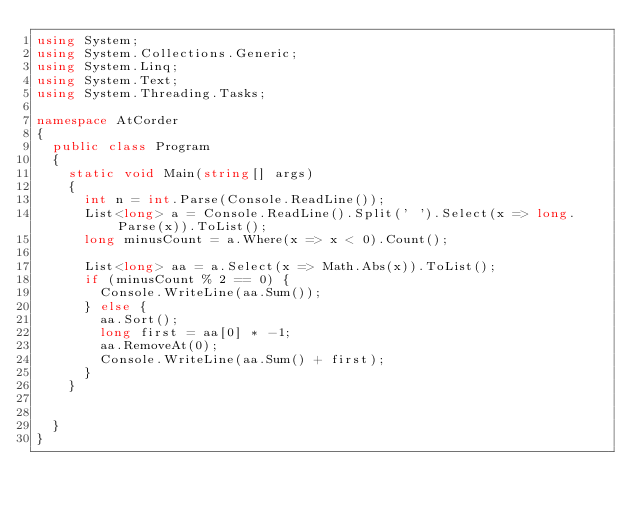<code> <loc_0><loc_0><loc_500><loc_500><_C#_>using System;
using System.Collections.Generic;
using System.Linq;
using System.Text;
using System.Threading.Tasks;

namespace AtCorder
{
	public class Program
	{
		static void Main(string[] args)
		{
			int n = int.Parse(Console.ReadLine());
			List<long> a = Console.ReadLine().Split(' ').Select(x => long.Parse(x)).ToList();
			long minusCount = a.Where(x => x < 0).Count();

			List<long> aa = a.Select(x => Math.Abs(x)).ToList();
			if (minusCount % 2 == 0) {
				Console.WriteLine(aa.Sum());
			} else {
				aa.Sort();
				long first = aa[0] * -1;
				aa.RemoveAt(0);
				Console.WriteLine(aa.Sum() + first);
			}
		}

		
	}
}
</code> 